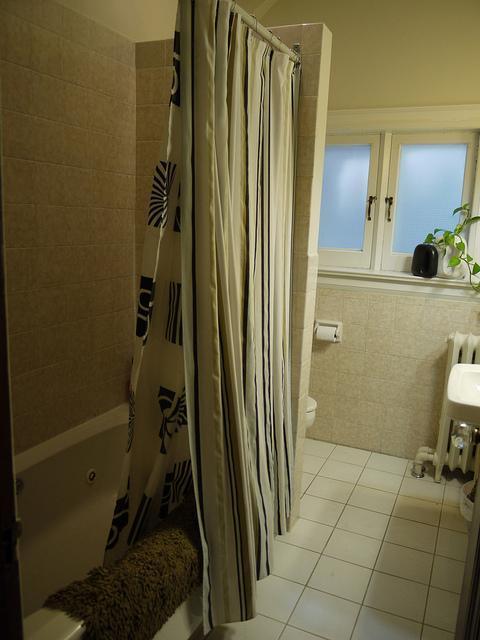How many windows are in the picture?
Give a very brief answer. 2. 